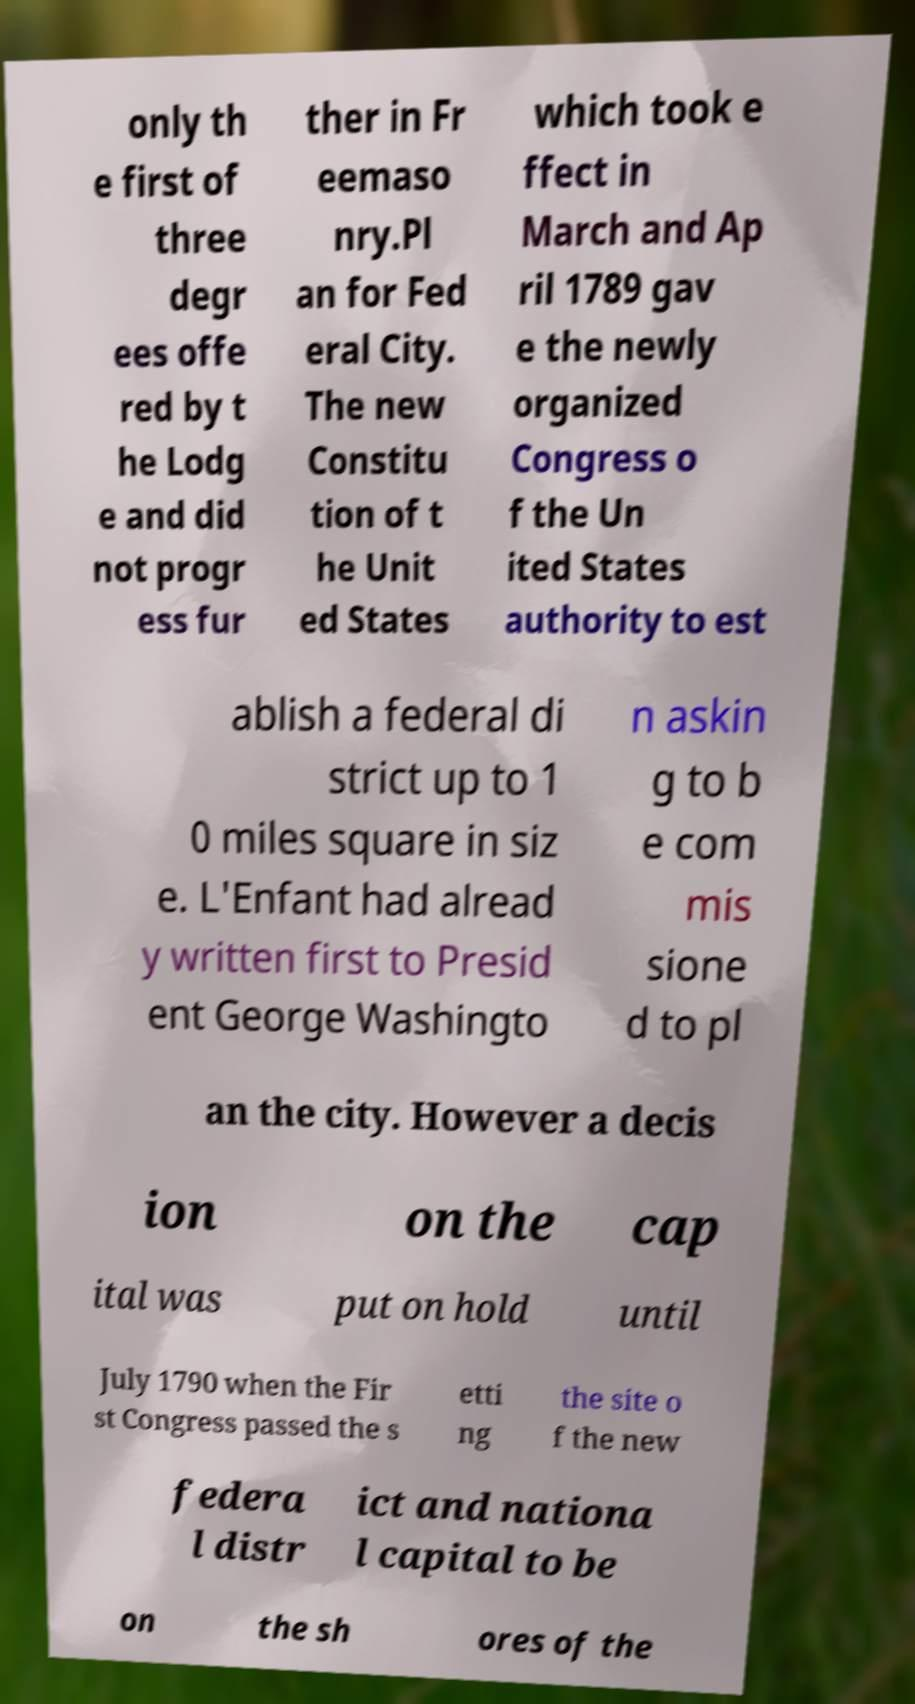Could you assist in decoding the text presented in this image and type it out clearly? only th e first of three degr ees offe red by t he Lodg e and did not progr ess fur ther in Fr eemaso nry.Pl an for Fed eral City. The new Constitu tion of t he Unit ed States which took e ffect in March and Ap ril 1789 gav e the newly organized Congress o f the Un ited States authority to est ablish a federal di strict up to 1 0 miles square in siz e. L'Enfant had alread y written first to Presid ent George Washingto n askin g to b e com mis sione d to pl an the city. However a decis ion on the cap ital was put on hold until July 1790 when the Fir st Congress passed the s etti ng the site o f the new federa l distr ict and nationa l capital to be on the sh ores of the 